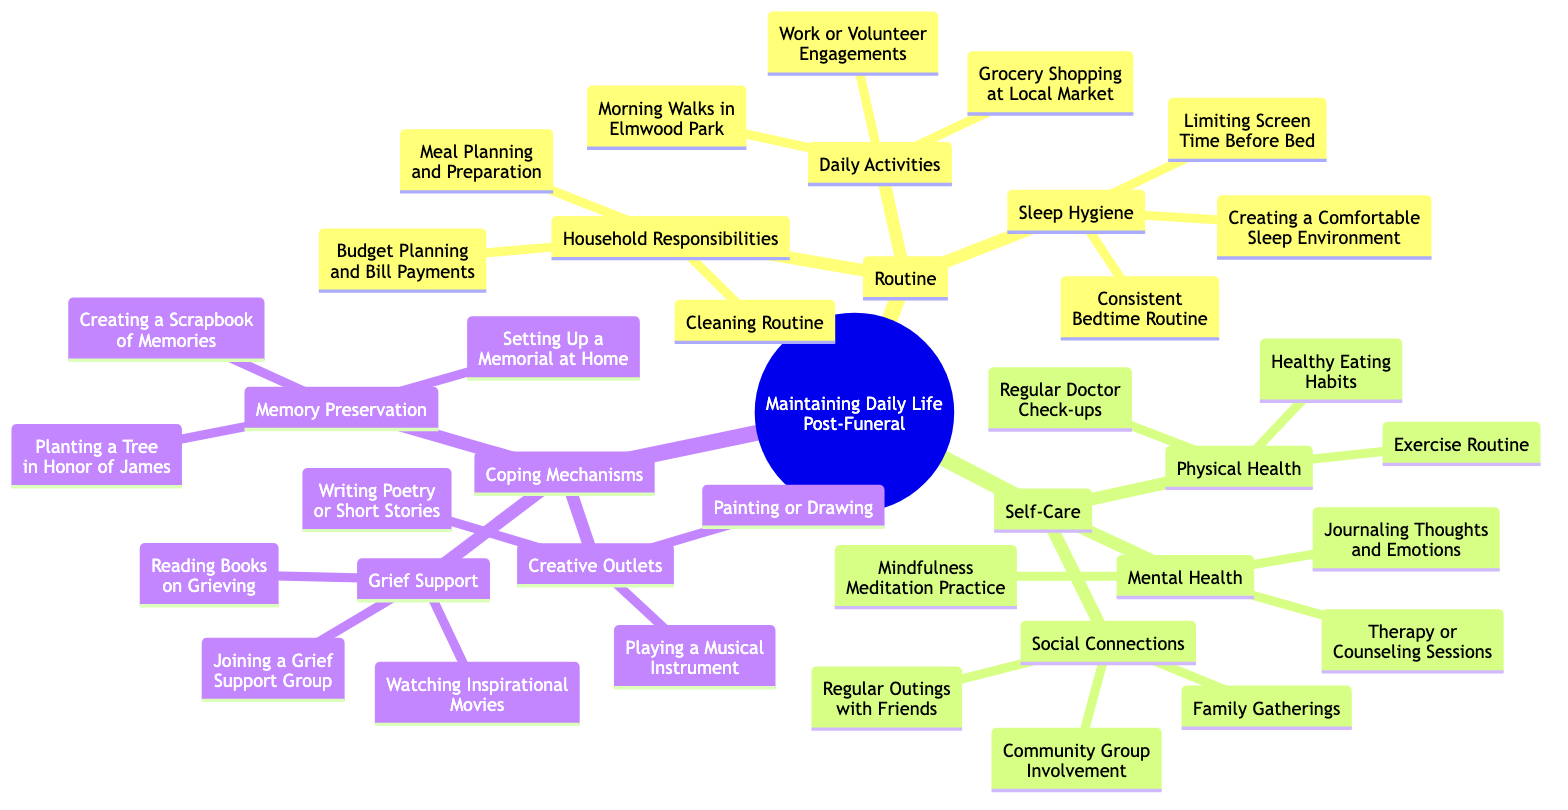What are three daily activities listed in the diagram? The diagram under "Routine" emphasizes "Daily Activities," which includes three specific examples: "Morning Walks in Elmwood Park," "Grocery Shopping at Local Market," and "Work or Volunteer Engagements."
Answer: Morning Walks in Elmwood Park, Grocery Shopping at Local Market, Work or Volunteer Engagements How many branches are there under "Self-Care"? In the diagram, the "Self-Care" section has three main branches: "Physical Health," "Mental Health," and "Social Connections," making the total number of branches three.
Answer: 3 What is one recommended coping mechanism for grief support? Under "Coping Mechanisms," the section for "Grief Support" lists several items; one of them is "Joining a Grief Support Group."
Answer: Joining a Grief Support Group Which daily activity could contribute to a consistent sleep hygiene? Among the "Daily Activities" listed, all contribute to daily life, but the "Consistent Bedtime Routine" is specifically under "Sleep Hygiene" and directly relates to maintaining good sleep habits.
Answer: Consistent Bedtime Routine What types of creative outlets are suggested? The diagram under "Coping Mechanisms" features a section titled "Creative Outlets" that includes three activities: "Painting or Drawing," "Playing a Musical Instrument," and "Writing Poetry or Short Stories."
Answer: Painting or Drawing, Playing a Musical Instrument, Writing Poetry or Short Stories How many total nodes are in the "Routine" section? The "Routine" section contains three main categories: "Daily Activities," "Household Responsibilities," and "Sleep Hygiene," and within them, a total of nine specific nodes can be counted when enumerating the individual items listed.
Answer: 9 What is a benefit of community group involvement listed? In the "Social Connections" part of "Self-Care," "Community Group Involvement" promotes connection with others, which can lead to enhanced feelings of support and belonging, thus contributing positively to well-being post-funeral.
Answer: Community Group Involvement Which mechanism is associated with memory preservation? The "Memory Preservation" part of the "Coping Mechanisms" includes actions like "Creating a Scrapbook of Memories" and "Planting a Tree in Honor of James," which focus on preserving the memory of a loved one.
Answer: Creating a Scrapbook of Memories 